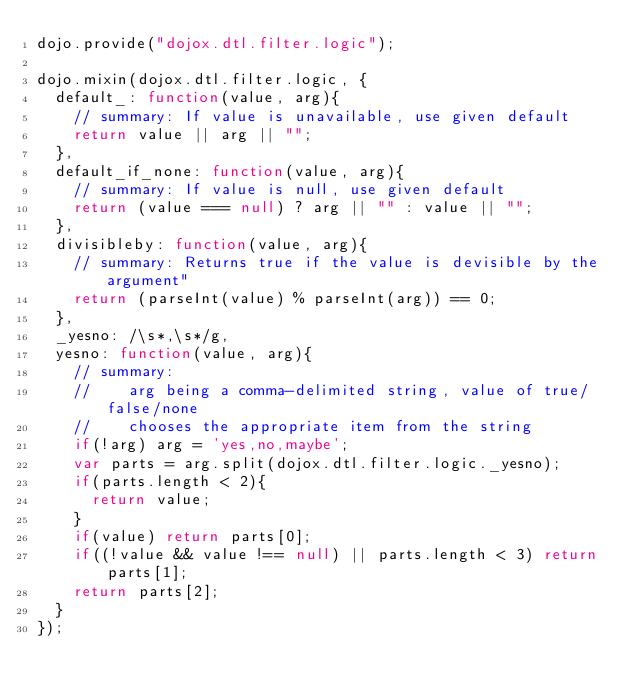<code> <loc_0><loc_0><loc_500><loc_500><_JavaScript_>dojo.provide("dojox.dtl.filter.logic");

dojo.mixin(dojox.dtl.filter.logic, {
	default_: function(value, arg){
		// summary: If value is unavailable, use given default
		return value || arg || "";
	},
	default_if_none: function(value, arg){
		// summary: If value is null, use given default
		return (value === null) ? arg || "" : value || "";
	},
	divisibleby: function(value, arg){
		// summary: Returns true if the value is devisible by the argument"
		return (parseInt(value) % parseInt(arg)) == 0;
	},
	_yesno: /\s*,\s*/g,
	yesno: function(value, arg){
		// summary:
		//		arg being a comma-delimited string, value of true/false/none
		//		chooses the appropriate item from the string
		if(!arg) arg = 'yes,no,maybe';
		var parts = arg.split(dojox.dtl.filter.logic._yesno);
		if(parts.length < 2){
			return value;
		}
		if(value) return parts[0];
		if((!value && value !== null) || parts.length < 3) return parts[1];
		return parts[2];
	}
});</code> 